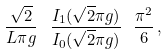<formula> <loc_0><loc_0><loc_500><loc_500>\frac { \sqrt { 2 } } { L \pi g } \ \frac { I _ { 1 } ( \sqrt { 2 } \pi g ) } { I _ { 0 } ( \sqrt { 2 } \pi g ) } \ \frac { \pi ^ { 2 } } { 6 } \, ,</formula> 